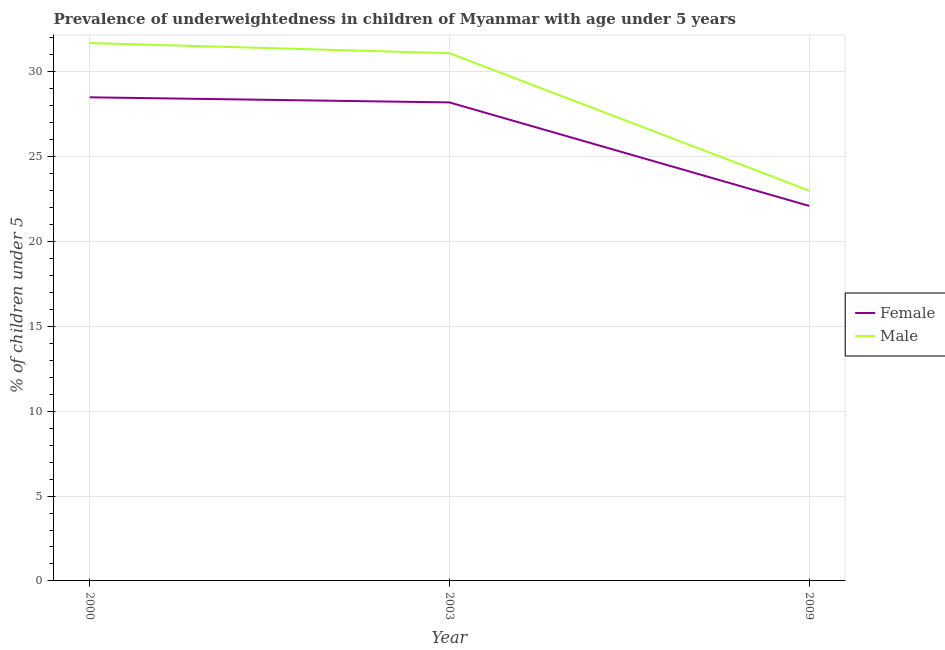Does the line corresponding to percentage of underweighted male children intersect with the line corresponding to percentage of underweighted female children?
Ensure brevity in your answer.  No. What is the percentage of underweighted female children in 2009?
Provide a succinct answer. 22.1. Across all years, what is the maximum percentage of underweighted male children?
Make the answer very short. 31.7. In which year was the percentage of underweighted female children maximum?
Ensure brevity in your answer.  2000. What is the total percentage of underweighted male children in the graph?
Your answer should be very brief. 85.8. What is the difference between the percentage of underweighted male children in 2003 and that in 2009?
Your answer should be compact. 8.1. What is the average percentage of underweighted male children per year?
Offer a very short reply. 28.6. In the year 2000, what is the difference between the percentage of underweighted female children and percentage of underweighted male children?
Provide a short and direct response. -3.2. What is the ratio of the percentage of underweighted female children in 2003 to that in 2009?
Offer a very short reply. 1.28. Is the percentage of underweighted male children in 2003 less than that in 2009?
Offer a terse response. No. Is the difference between the percentage of underweighted male children in 2003 and 2009 greater than the difference between the percentage of underweighted female children in 2003 and 2009?
Your answer should be compact. Yes. What is the difference between the highest and the second highest percentage of underweighted male children?
Offer a terse response. 0.6. What is the difference between the highest and the lowest percentage of underweighted male children?
Ensure brevity in your answer.  8.7. In how many years, is the percentage of underweighted male children greater than the average percentage of underweighted male children taken over all years?
Your answer should be compact. 2. Is the sum of the percentage of underweighted male children in 2000 and 2009 greater than the maximum percentage of underweighted female children across all years?
Provide a succinct answer. Yes. Is the percentage of underweighted female children strictly greater than the percentage of underweighted male children over the years?
Ensure brevity in your answer.  No. Are the values on the major ticks of Y-axis written in scientific E-notation?
Your answer should be very brief. No. Does the graph contain any zero values?
Make the answer very short. No. Does the graph contain grids?
Keep it short and to the point. Yes. How are the legend labels stacked?
Offer a very short reply. Vertical. What is the title of the graph?
Provide a short and direct response. Prevalence of underweightedness in children of Myanmar with age under 5 years. What is the label or title of the X-axis?
Your answer should be compact. Year. What is the label or title of the Y-axis?
Your answer should be compact.  % of children under 5. What is the  % of children under 5 in Male in 2000?
Offer a very short reply. 31.7. What is the  % of children under 5 of Female in 2003?
Offer a very short reply. 28.2. What is the  % of children under 5 in Male in 2003?
Offer a very short reply. 31.1. What is the  % of children under 5 in Female in 2009?
Provide a succinct answer. 22.1. Across all years, what is the maximum  % of children under 5 in Female?
Your answer should be compact. 28.5. Across all years, what is the maximum  % of children under 5 of Male?
Ensure brevity in your answer.  31.7. Across all years, what is the minimum  % of children under 5 in Female?
Provide a short and direct response. 22.1. What is the total  % of children under 5 in Female in the graph?
Make the answer very short. 78.8. What is the total  % of children under 5 in Male in the graph?
Keep it short and to the point. 85.8. What is the difference between the  % of children under 5 of Male in 2000 and that in 2003?
Offer a very short reply. 0.6. What is the difference between the  % of children under 5 of Female in 2000 and that in 2009?
Provide a short and direct response. 6.4. What is the difference between the  % of children under 5 of Female in 2003 and that in 2009?
Your response must be concise. 6.1. What is the difference between the  % of children under 5 in Female in 2000 and the  % of children under 5 in Male in 2009?
Your response must be concise. 5.5. What is the difference between the  % of children under 5 in Female in 2003 and the  % of children under 5 in Male in 2009?
Give a very brief answer. 5.2. What is the average  % of children under 5 of Female per year?
Make the answer very short. 26.27. What is the average  % of children under 5 of Male per year?
Your response must be concise. 28.6. What is the ratio of the  % of children under 5 of Female in 2000 to that in 2003?
Offer a terse response. 1.01. What is the ratio of the  % of children under 5 in Male in 2000 to that in 2003?
Ensure brevity in your answer.  1.02. What is the ratio of the  % of children under 5 of Female in 2000 to that in 2009?
Ensure brevity in your answer.  1.29. What is the ratio of the  % of children under 5 in Male in 2000 to that in 2009?
Provide a short and direct response. 1.38. What is the ratio of the  % of children under 5 in Female in 2003 to that in 2009?
Your response must be concise. 1.28. What is the ratio of the  % of children under 5 in Male in 2003 to that in 2009?
Ensure brevity in your answer.  1.35. What is the difference between the highest and the second highest  % of children under 5 in Female?
Provide a short and direct response. 0.3. What is the difference between the highest and the second highest  % of children under 5 in Male?
Your response must be concise. 0.6. What is the difference between the highest and the lowest  % of children under 5 of Male?
Keep it short and to the point. 8.7. 